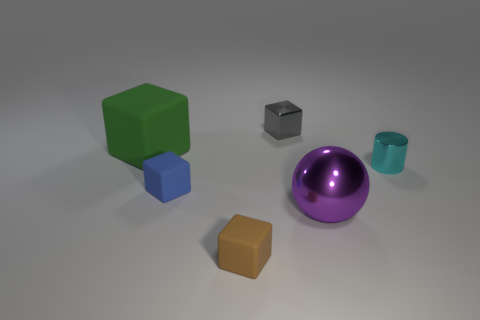Add 4 blue shiny cylinders. How many objects exist? 10 Subtract all blocks. How many objects are left? 2 Add 4 big gray balls. How many big gray balls exist? 4 Subtract 1 blue blocks. How many objects are left? 5 Subtract all tiny gray shiny cubes. Subtract all gray rubber cylinders. How many objects are left? 5 Add 6 tiny cyan shiny cylinders. How many tiny cyan shiny cylinders are left? 7 